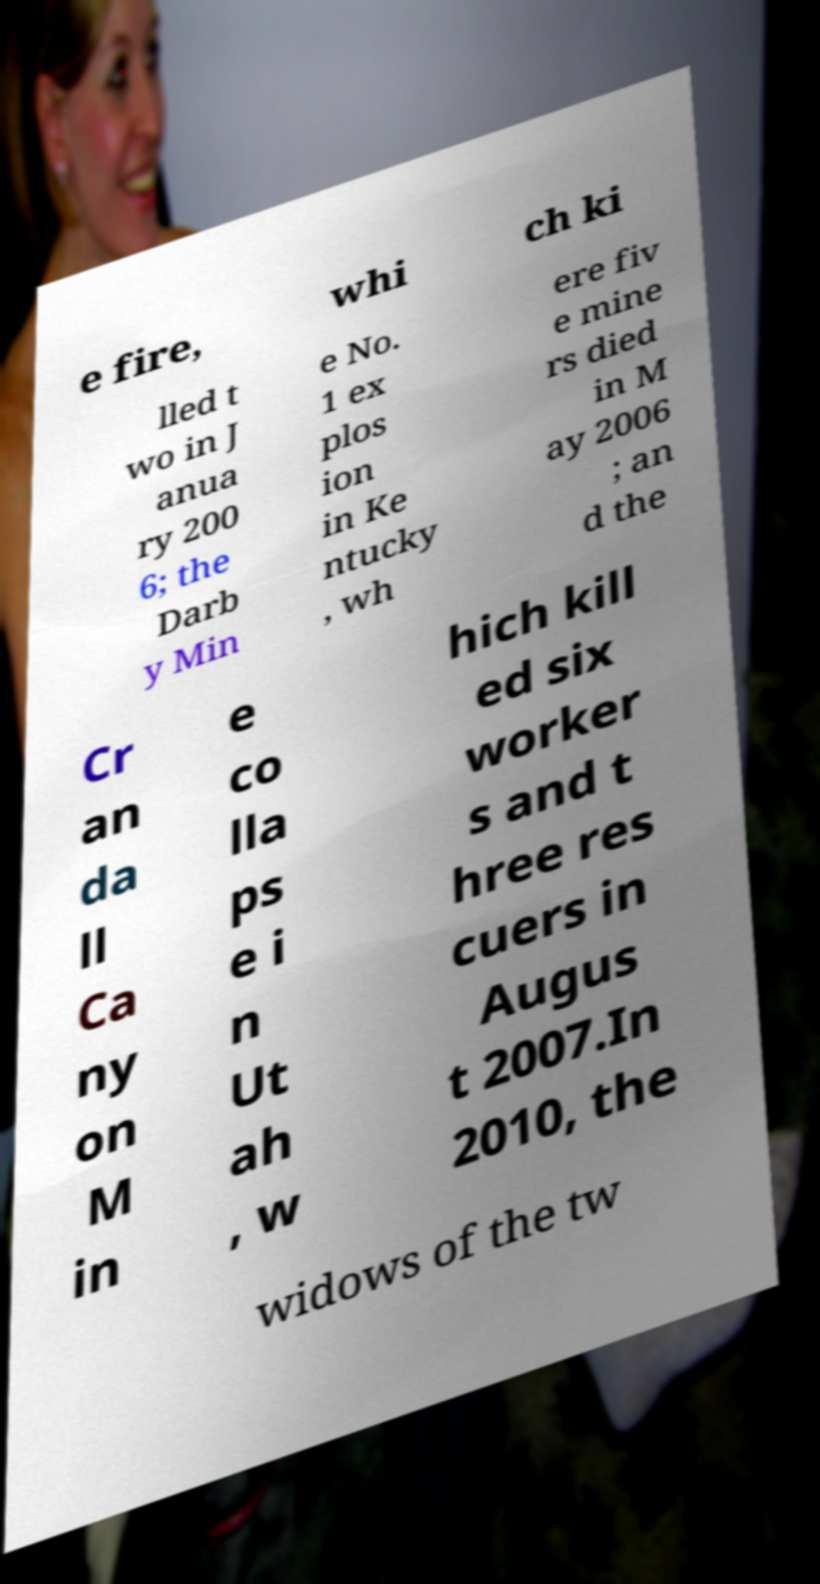I need the written content from this picture converted into text. Can you do that? e fire, whi ch ki lled t wo in J anua ry 200 6; the Darb y Min e No. 1 ex plos ion in Ke ntucky , wh ere fiv e mine rs died in M ay 2006 ; an d the Cr an da ll Ca ny on M in e co lla ps e i n Ut ah , w hich kill ed six worker s and t hree res cuers in Augus t 2007.In 2010, the widows of the tw 